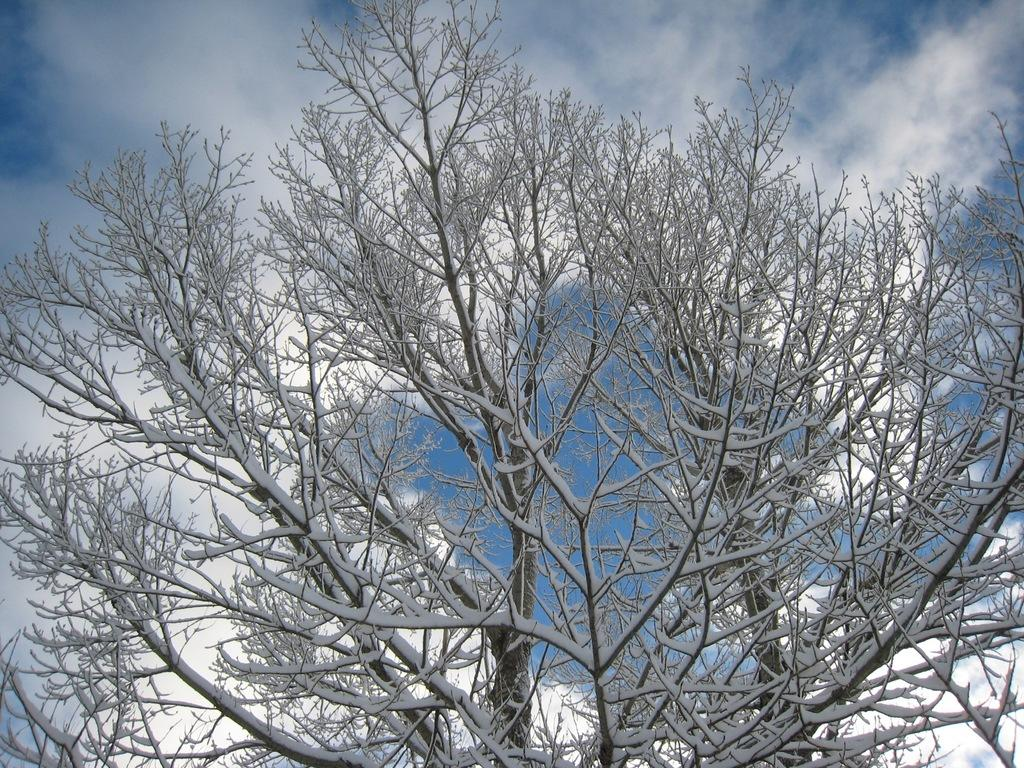What is the main subject of the image? The main subject of the image is a tree. How is the tree in the image affected by the weather? The tree is covered with snow in the image. What can be seen in the background of the image? Sky is visible in the background of the image. What is the condition of the sky in the image? Clouds are present in the sky in the image. How much dirt is visible on the tree in the image? There is no dirt visible on the tree in the image, as it is covered with snow. What type of muscle can be seen flexing in the image? There are no muscles present in the image; it features a tree covered with snow and a sky with clouds. 